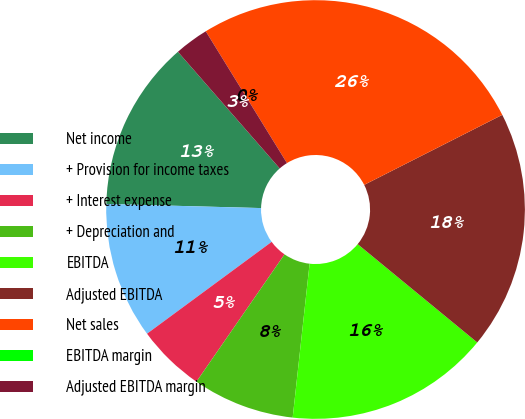Convert chart. <chart><loc_0><loc_0><loc_500><loc_500><pie_chart><fcel>Net income<fcel>+ Provision for income taxes<fcel>+ Interest expense<fcel>+ Depreciation and<fcel>EBITDA<fcel>Adjusted EBITDA<fcel>Net sales<fcel>EBITDA margin<fcel>Adjusted EBITDA margin<nl><fcel>13.16%<fcel>10.53%<fcel>5.26%<fcel>7.89%<fcel>15.79%<fcel>18.42%<fcel>26.32%<fcel>0.0%<fcel>2.63%<nl></chart> 